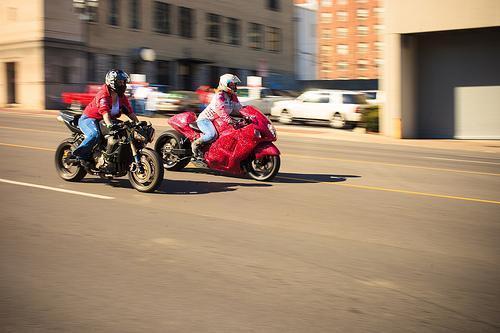How many riders are there?
Give a very brief answer. 2. 